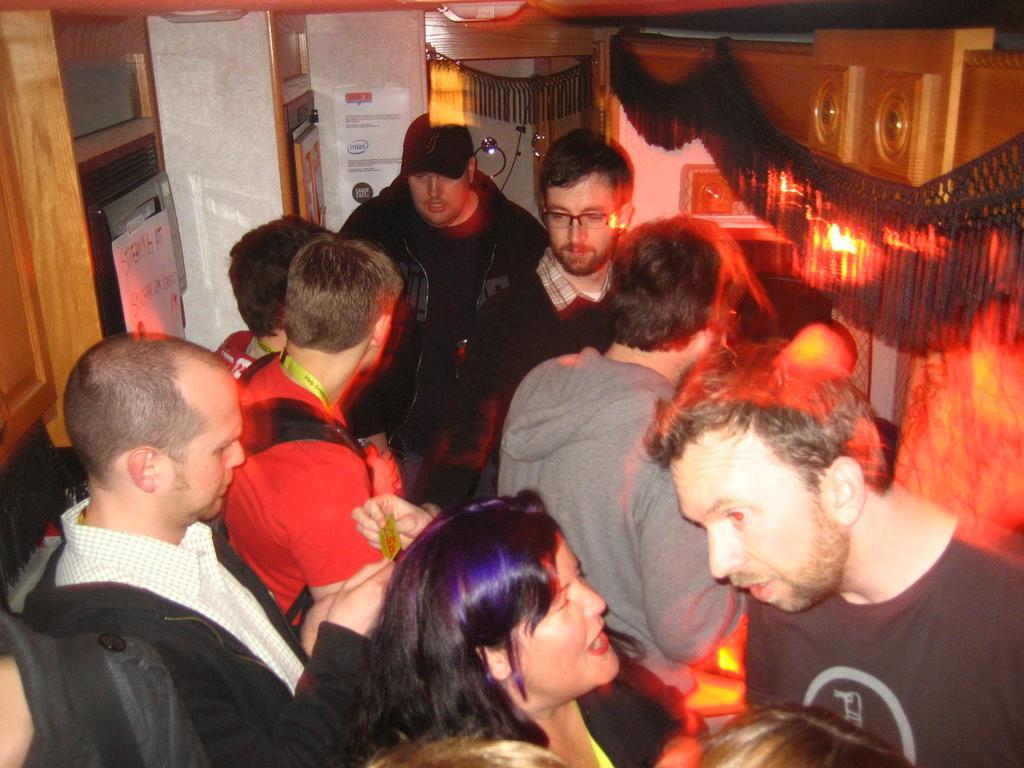In one or two sentences, can you explain what this image depicts? In the center of the image there are few people. In the background of the image there is a door. To the right side of the image there is a wooden arch. 